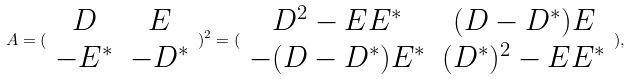Convert formula to latex. <formula><loc_0><loc_0><loc_500><loc_500>A = ( \begin{array} { c c } D & E \\ - E ^ { \ast } & - D ^ { \ast } \end{array} ) ^ { 2 } = ( \begin{array} { c c } D ^ { 2 } - E E ^ { \ast } & ( D - D ^ { \ast } ) E \\ - ( D - D ^ { \ast } ) E ^ { \ast } & ( D ^ { \ast } ) ^ { 2 } - E E ^ { \ast } \end{array} ) ,</formula> 